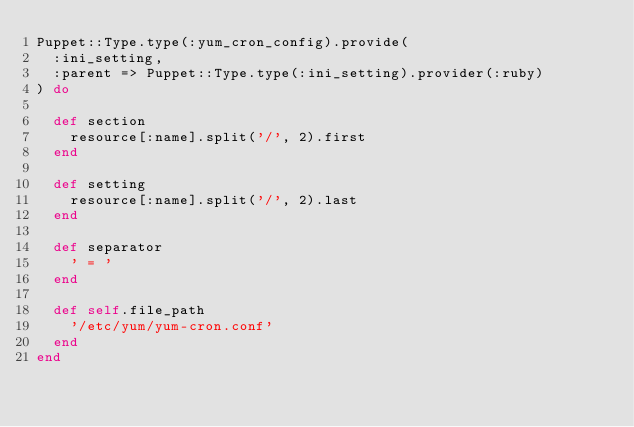<code> <loc_0><loc_0><loc_500><loc_500><_Ruby_>Puppet::Type.type(:yum_cron_config).provide(
  :ini_setting,
  :parent => Puppet::Type.type(:ini_setting).provider(:ruby)
) do

  def section
    resource[:name].split('/', 2).first
  end

  def setting
    resource[:name].split('/', 2).last
  end

  def separator
    ' = '
  end

  def self.file_path
    '/etc/yum/yum-cron.conf'
  end
end
</code> 